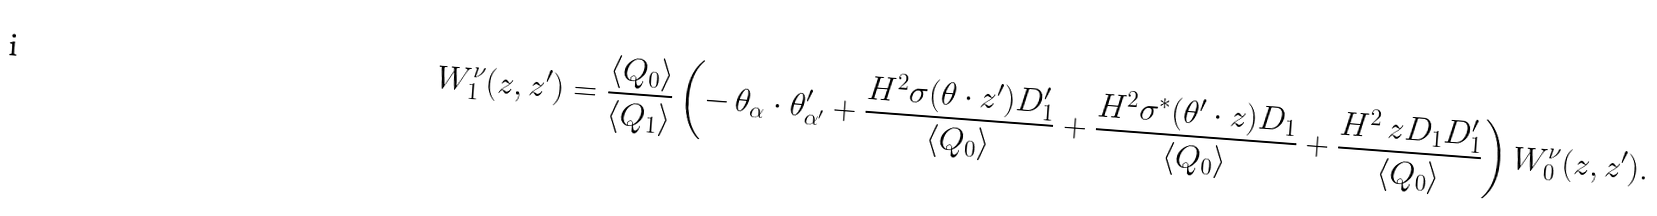Convert formula to latex. <formula><loc_0><loc_0><loc_500><loc_500>W ^ { \nu } _ { 1 } ( z , z ^ { \prime } ) = \frac { \langle Q _ { 0 } \rangle } { \langle Q _ { 1 } \rangle } \left ( - \, \theta _ { \alpha } \cdot \theta ^ { \prime } _ { \alpha ^ { \prime } } + \frac { H ^ { 2 } \sigma ( \theta \cdot z ^ { \prime } ) D ^ { \prime } _ { 1 } } { \langle Q _ { 0 } \rangle } + \frac { H ^ { 2 } \sigma ^ { * } ( \theta ^ { \prime } \cdot z ) D _ { 1 } } { \langle Q _ { 0 } \rangle } + \frac { H ^ { 2 } \ z D _ { 1 } D ^ { \prime } _ { 1 } } { \langle Q _ { 0 } \rangle } \right ) W ^ { \nu } _ { 0 } ( z , z ^ { \prime } ) .</formula> 